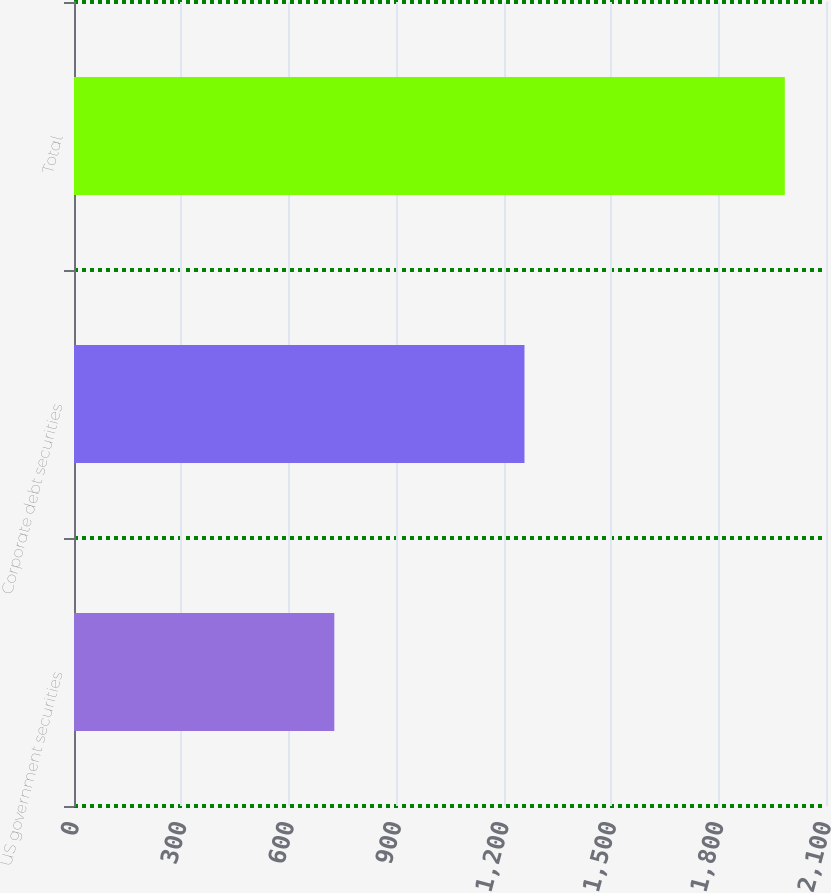Convert chart. <chart><loc_0><loc_0><loc_500><loc_500><bar_chart><fcel>US government securities<fcel>Corporate debt securities<fcel>Total<nl><fcel>727<fcel>1258<fcel>1985<nl></chart> 